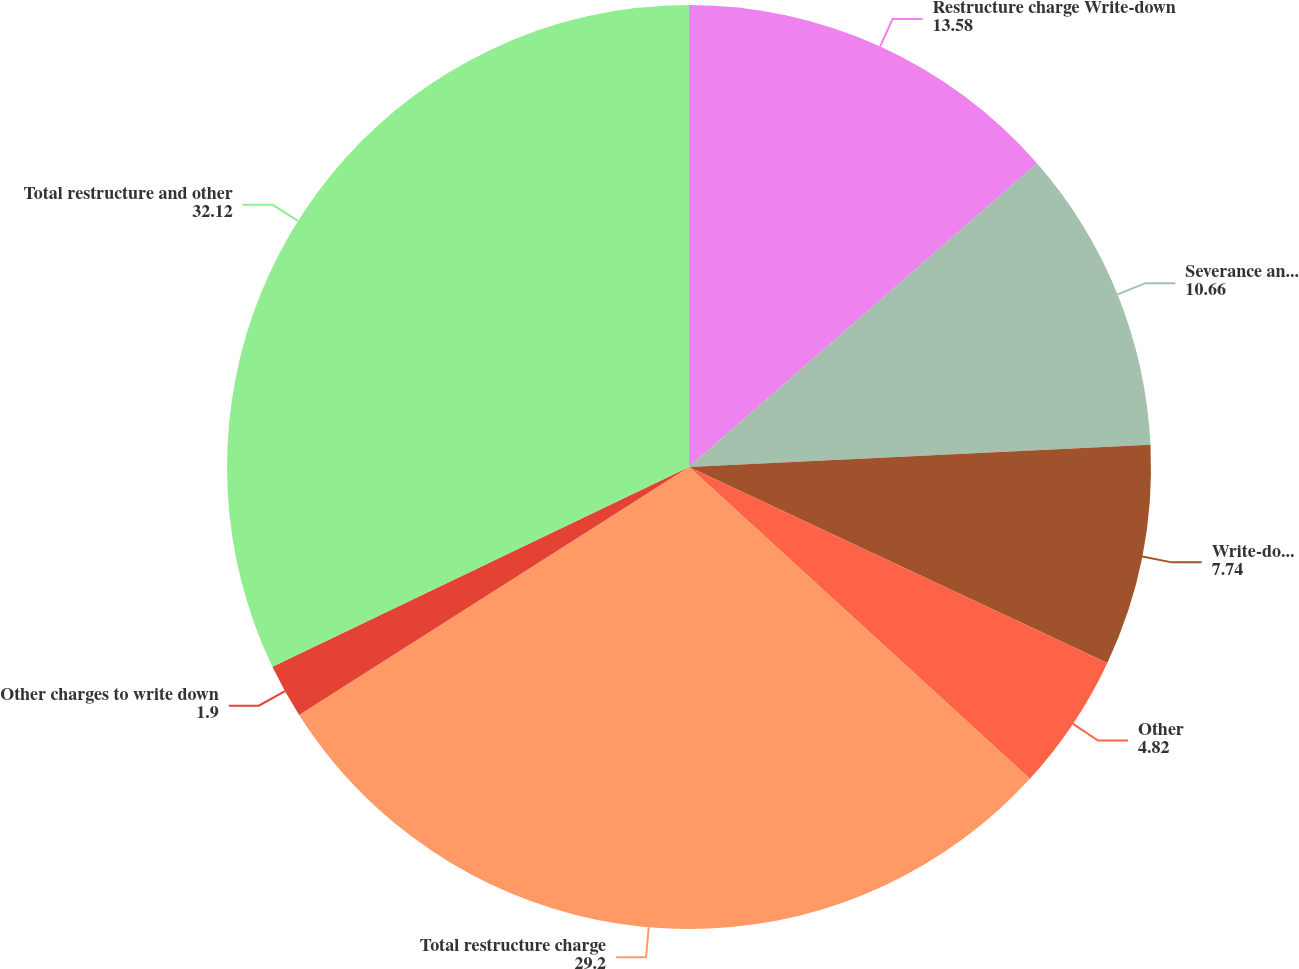Convert chart. <chart><loc_0><loc_0><loc_500><loc_500><pie_chart><fcel>Restructure charge Write-down<fcel>Severance and other<fcel>Write-down of intangible<fcel>Other<fcel>Total restructure charge<fcel>Other charges to write down<fcel>Total restructure and other<nl><fcel>13.58%<fcel>10.66%<fcel>7.74%<fcel>4.82%<fcel>29.2%<fcel>1.9%<fcel>32.12%<nl></chart> 